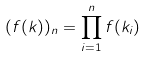Convert formula to latex. <formula><loc_0><loc_0><loc_500><loc_500>( f ( k ) ) _ { n } = \prod _ { i = 1 } ^ { n } f ( k _ { i } )</formula> 